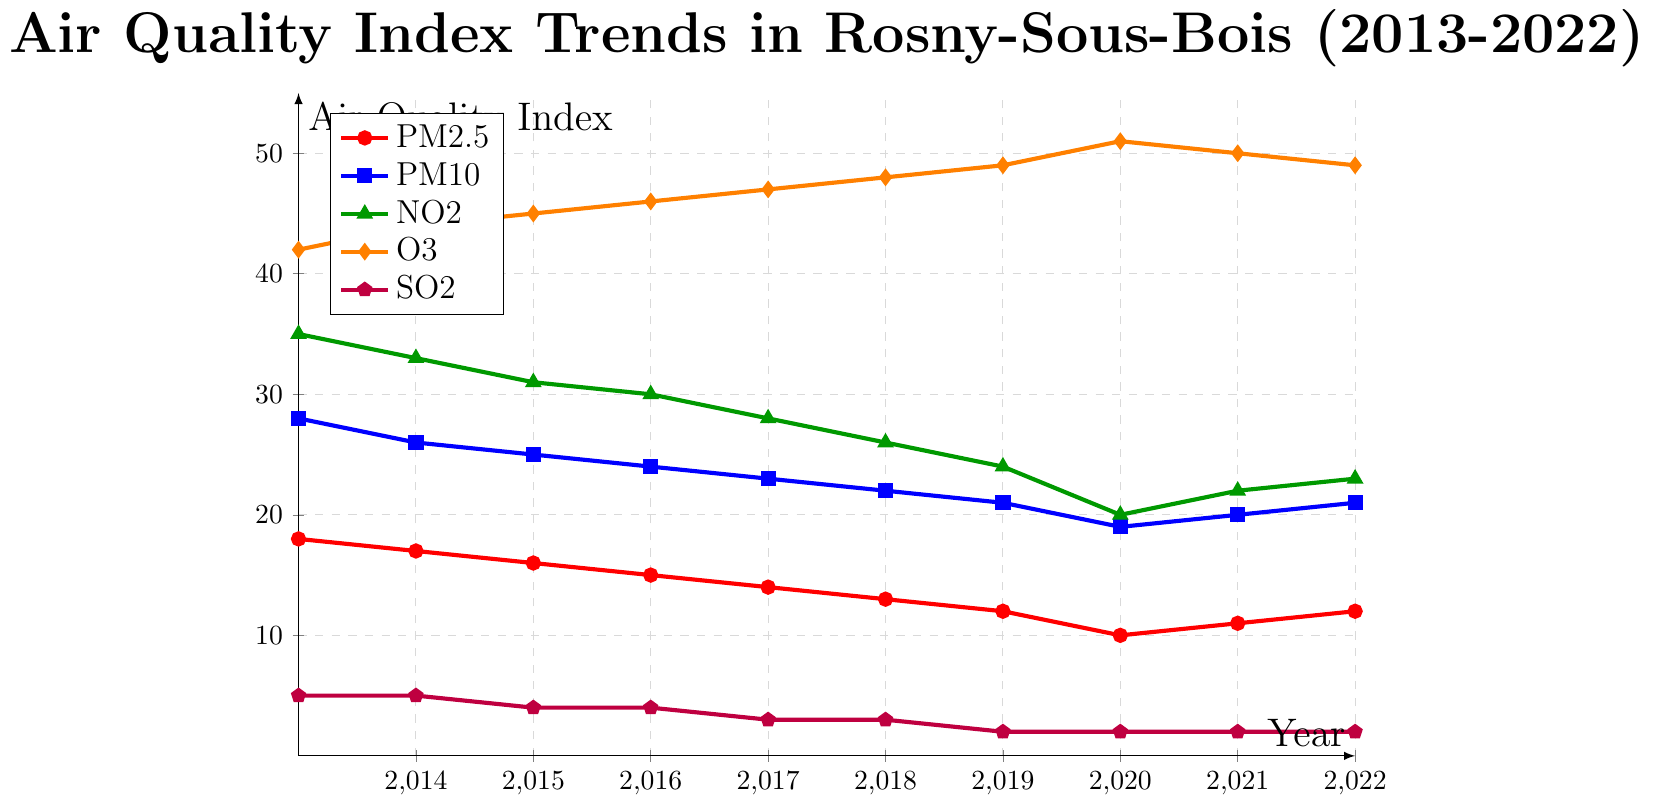what is the overall trend of PM2.5 from 2013 to 2022? The red line representing PM2.5 shows a generally decreasing trend from 18 in 2013 to 12 in 2022, reaching its lowest value of 10 in 2020. However, there is a slight increase from 2020 to 2022.
Answer: overall decreasing Which pollutant had the highest value in 2020? The highest value among pollutants in 2020 is indicated by the orange line representing O3, which peaks at 51.
Answer: O3 What is the difference in PM10 levels between 2013 and 2016? The PM10 level in 2013 is 28 and in 2016 is 24. The difference is 28 - 24 = 4.
Answer: 4 In which years did the SO2 levels remain constant? The purple line for SO2 remains constant at 5 from 2013 to 2014 and then at 2 from 2019 to 2022.
Answer: 2013-2014, 2019-2022 Which two pollutants had the smallest values in 2013? In 2013, the smallest pollutant values are SO2 (5) and PM2.5 (18). This can be seen as the purple and red lines have the lowest y-values.
Answer: SO2 and PM2.5 Calculate the average value of NO2 from 2013 to 2022. Adding the NO2 values: 35+33+31+30+28+26+24+20+22+23 = 272. Divide by 10 years to get the average: 272/10 = 27.2.
Answer: 27.2 Which pollutant shows an increasing trend from 2013 to 2022? The orange line representing O3 shows a clear general increasing trend from 42 in 2013 to 49 in 2022, peaking at 51 in 2020.
Answer: O3 How many pollutants decreased in value from 2013 to 2022? Pollutants PM2.5, PM10, NO2, and SO2 all show a decrease from 2013 to 2022.
Answer: 4 Was there any year when PM2.5 and NO2 had the same value? By checking the points of the red (PM2.5) and green (NO2) lines, there is no year where both pollutants had the same value.
Answer: No Which pollutant has the steepest decline between 2013 and 2020? The steepest decline can be observed in the green (NO2) line, which falls from 35 to 20 (a decline of 15 units).
Answer: NO2 